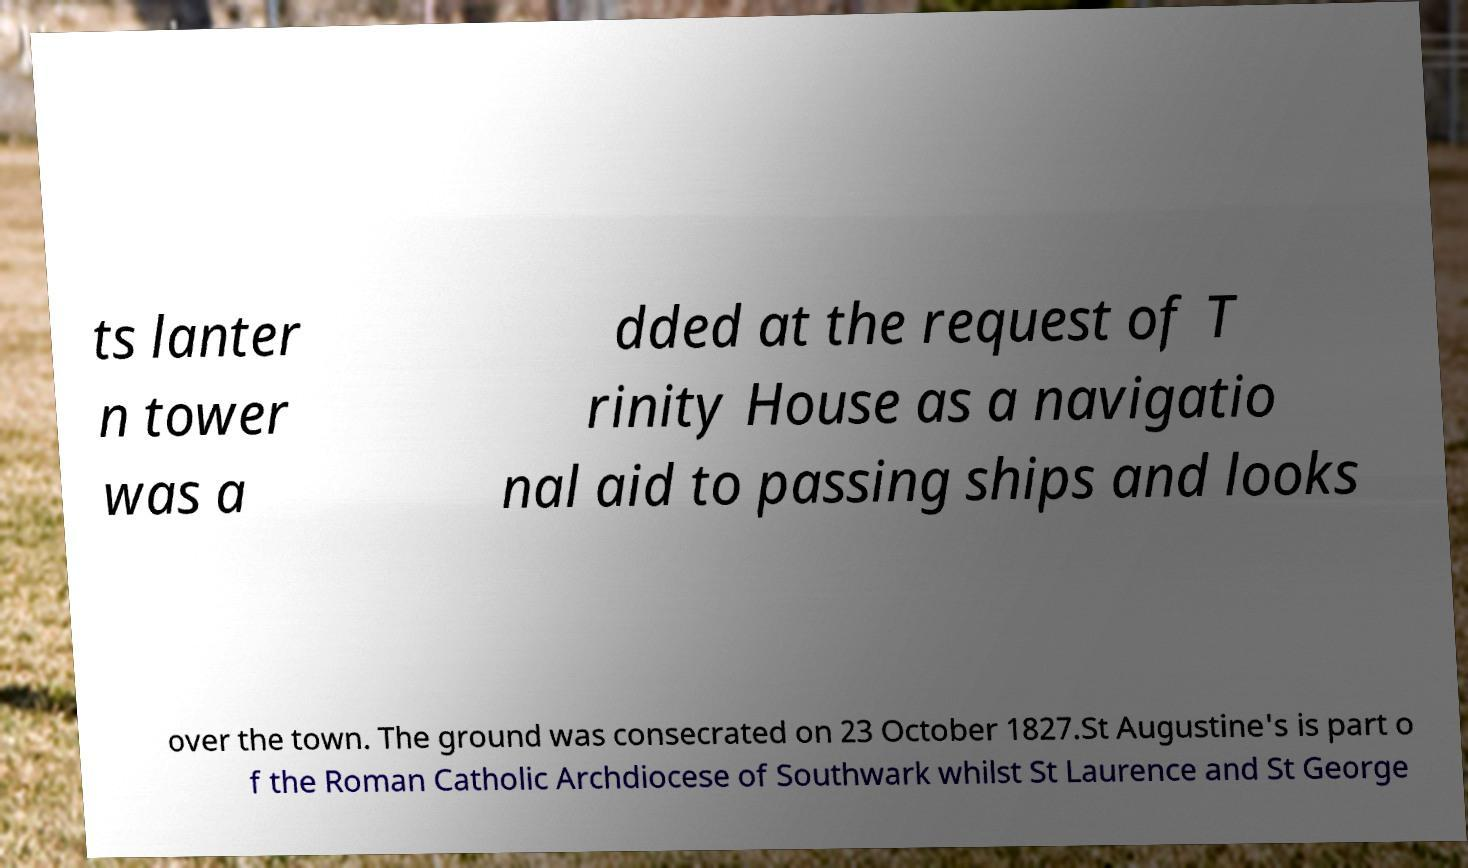Could you extract and type out the text from this image? ts lanter n tower was a dded at the request of T rinity House as a navigatio nal aid to passing ships and looks over the town. The ground was consecrated on 23 October 1827.St Augustine's is part o f the Roman Catholic Archdiocese of Southwark whilst St Laurence and St George 